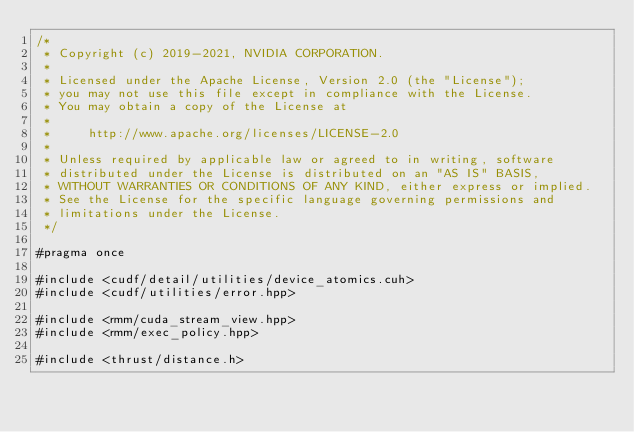Convert code to text. <code><loc_0><loc_0><loc_500><loc_500><_Cuda_>/*
 * Copyright (c) 2019-2021, NVIDIA CORPORATION.
 *
 * Licensed under the Apache License, Version 2.0 (the "License");
 * you may not use this file except in compliance with the License.
 * You may obtain a copy of the License at
 *
 *     http://www.apache.org/licenses/LICENSE-2.0
 *
 * Unless required by applicable law or agreed to in writing, software
 * distributed under the License is distributed on an "AS IS" BASIS,
 * WITHOUT WARRANTIES OR CONDITIONS OF ANY KIND, either express or implied.
 * See the License for the specific language governing permissions and
 * limitations under the License.
 */

#pragma once

#include <cudf/detail/utilities/device_atomics.cuh>
#include <cudf/utilities/error.hpp>

#include <rmm/cuda_stream_view.hpp>
#include <rmm/exec_policy.hpp>

#include <thrust/distance.h></code> 